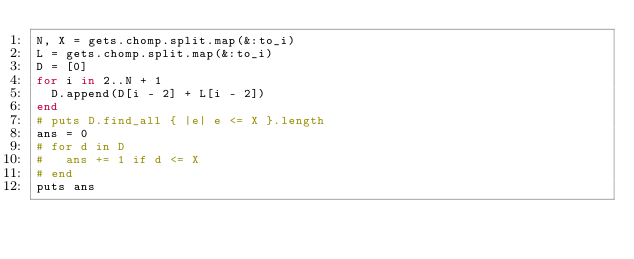Convert code to text. <code><loc_0><loc_0><loc_500><loc_500><_Ruby_>N, X = gets.chomp.split.map(&:to_i)
L = gets.chomp.split.map(&:to_i)
D = [0]
for i in 2..N + 1
  D.append(D[i - 2] + L[i - 2])
end
# puts D.find_all { |e| e <= X }.length
ans = 0
# for d in D
#   ans += 1 if d <= X
# end
puts ans
</code> 